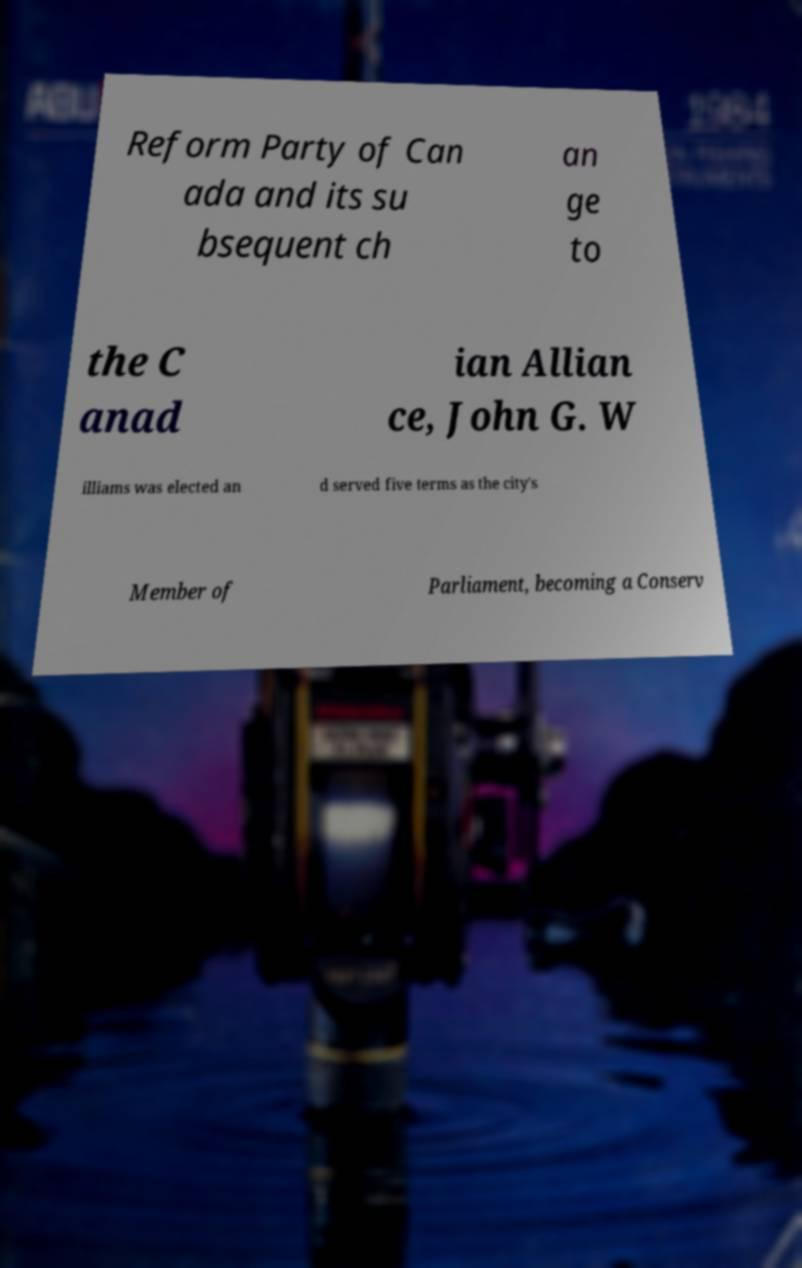What messages or text are displayed in this image? I need them in a readable, typed format. Reform Party of Can ada and its su bsequent ch an ge to the C anad ian Allian ce, John G. W illiams was elected an d served five terms as the city's Member of Parliament, becoming a Conserv 